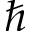Convert formula to latex. <formula><loc_0><loc_0><loc_500><loc_500>\hbar</formula> 